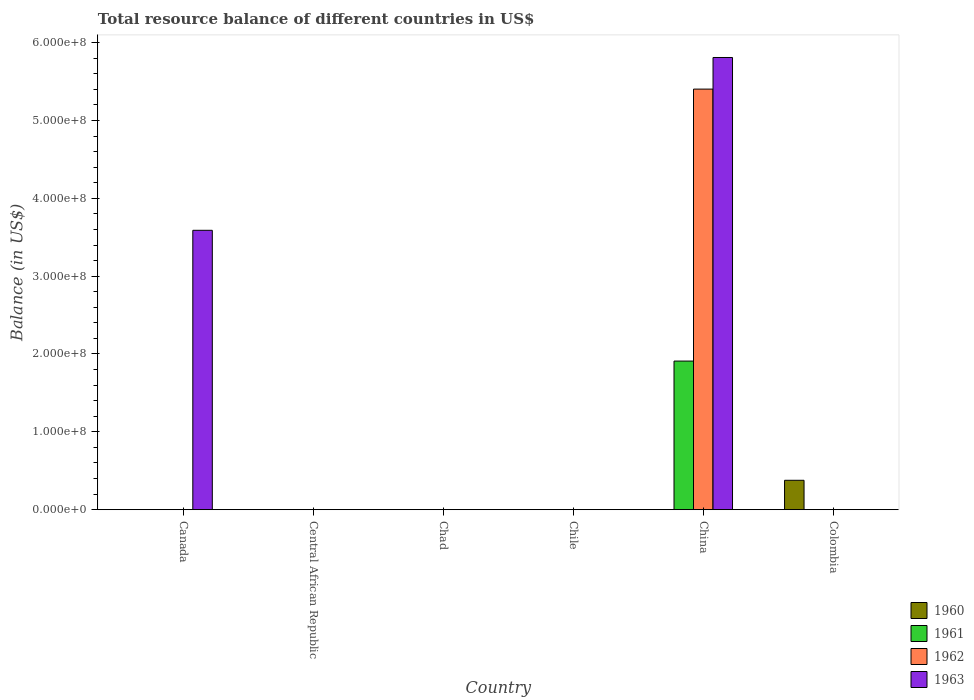Are the number of bars per tick equal to the number of legend labels?
Ensure brevity in your answer.  No. How many bars are there on the 2nd tick from the left?
Ensure brevity in your answer.  0. What is the label of the 3rd group of bars from the left?
Your response must be concise. Chad. In how many cases, is the number of bars for a given country not equal to the number of legend labels?
Offer a terse response. 6. What is the total resource balance in 1963 in China?
Your answer should be compact. 5.81e+08. Across all countries, what is the maximum total resource balance in 1961?
Provide a succinct answer. 1.91e+08. What is the total total resource balance in 1963 in the graph?
Keep it short and to the point. 9.40e+08. What is the average total resource balance in 1961 per country?
Offer a terse response. 3.18e+07. What is the difference between the highest and the lowest total resource balance in 1963?
Your answer should be compact. 5.81e+08. Is it the case that in every country, the sum of the total resource balance in 1963 and total resource balance in 1961 is greater than the total resource balance in 1962?
Make the answer very short. No. How many bars are there?
Your answer should be compact. 5. Are all the bars in the graph horizontal?
Offer a terse response. No. Are the values on the major ticks of Y-axis written in scientific E-notation?
Offer a very short reply. Yes. Does the graph contain grids?
Your answer should be compact. No. How many legend labels are there?
Provide a succinct answer. 4. How are the legend labels stacked?
Give a very brief answer. Vertical. What is the title of the graph?
Provide a short and direct response. Total resource balance of different countries in US$. Does "2003" appear as one of the legend labels in the graph?
Keep it short and to the point. No. What is the label or title of the Y-axis?
Your answer should be very brief. Balance (in US$). What is the Balance (in US$) in 1960 in Canada?
Your answer should be very brief. 0. What is the Balance (in US$) in 1963 in Canada?
Your response must be concise. 3.59e+08. What is the Balance (in US$) in 1960 in Central African Republic?
Ensure brevity in your answer.  0. What is the Balance (in US$) of 1962 in Central African Republic?
Keep it short and to the point. 0. What is the Balance (in US$) in 1961 in Chad?
Keep it short and to the point. 0. What is the Balance (in US$) of 1963 in Chad?
Offer a terse response. 0. What is the Balance (in US$) of 1961 in China?
Provide a short and direct response. 1.91e+08. What is the Balance (in US$) of 1962 in China?
Offer a terse response. 5.40e+08. What is the Balance (in US$) of 1963 in China?
Your answer should be compact. 5.81e+08. What is the Balance (in US$) in 1960 in Colombia?
Provide a succinct answer. 3.78e+07. What is the Balance (in US$) of 1961 in Colombia?
Give a very brief answer. 0. What is the Balance (in US$) in 1962 in Colombia?
Your answer should be very brief. 0. What is the Balance (in US$) in 1963 in Colombia?
Your answer should be compact. 0. Across all countries, what is the maximum Balance (in US$) in 1960?
Provide a short and direct response. 3.78e+07. Across all countries, what is the maximum Balance (in US$) of 1961?
Ensure brevity in your answer.  1.91e+08. Across all countries, what is the maximum Balance (in US$) of 1962?
Make the answer very short. 5.40e+08. Across all countries, what is the maximum Balance (in US$) of 1963?
Provide a succinct answer. 5.81e+08. Across all countries, what is the minimum Balance (in US$) of 1960?
Make the answer very short. 0. Across all countries, what is the minimum Balance (in US$) in 1961?
Keep it short and to the point. 0. What is the total Balance (in US$) in 1960 in the graph?
Ensure brevity in your answer.  3.78e+07. What is the total Balance (in US$) of 1961 in the graph?
Provide a succinct answer. 1.91e+08. What is the total Balance (in US$) in 1962 in the graph?
Offer a very short reply. 5.40e+08. What is the total Balance (in US$) in 1963 in the graph?
Provide a succinct answer. 9.40e+08. What is the difference between the Balance (in US$) of 1963 in Canada and that in China?
Keep it short and to the point. -2.22e+08. What is the average Balance (in US$) in 1960 per country?
Offer a very short reply. 6.30e+06. What is the average Balance (in US$) of 1961 per country?
Give a very brief answer. 3.18e+07. What is the average Balance (in US$) of 1962 per country?
Your answer should be very brief. 9.00e+07. What is the average Balance (in US$) in 1963 per country?
Provide a short and direct response. 1.57e+08. What is the difference between the Balance (in US$) in 1961 and Balance (in US$) in 1962 in China?
Provide a short and direct response. -3.49e+08. What is the difference between the Balance (in US$) of 1961 and Balance (in US$) of 1963 in China?
Give a very brief answer. -3.90e+08. What is the difference between the Balance (in US$) in 1962 and Balance (in US$) in 1963 in China?
Your answer should be very brief. -4.06e+07. What is the ratio of the Balance (in US$) in 1963 in Canada to that in China?
Provide a short and direct response. 0.62. What is the difference between the highest and the lowest Balance (in US$) in 1960?
Your answer should be compact. 3.78e+07. What is the difference between the highest and the lowest Balance (in US$) of 1961?
Your answer should be very brief. 1.91e+08. What is the difference between the highest and the lowest Balance (in US$) in 1962?
Make the answer very short. 5.40e+08. What is the difference between the highest and the lowest Balance (in US$) of 1963?
Give a very brief answer. 5.81e+08. 